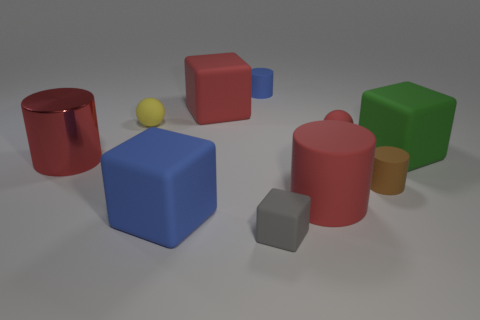The blue block that is made of the same material as the tiny brown object is what size?
Provide a short and direct response. Large. Are there any blue metal things that have the same size as the gray thing?
Offer a terse response. No. What shape is the blue matte thing behind the big red matte thing behind the tiny rubber cylinder on the right side of the tiny cube?
Your answer should be very brief. Cylinder. Is the number of brown objects right of the large red block greater than the number of big gray rubber spheres?
Offer a terse response. Yes. Is there a large green object of the same shape as the gray rubber object?
Ensure brevity in your answer.  Yes. Is the small yellow ball made of the same material as the big red cylinder that is to the right of the small yellow thing?
Offer a terse response. Yes. What is the color of the metallic thing?
Give a very brief answer. Red. There is a cylinder behind the matte ball on the left side of the red matte cube; what number of big blue matte blocks are in front of it?
Your answer should be compact. 1. Are there any red matte spheres on the left side of the tiny red rubber ball?
Provide a short and direct response. No. How many small brown cylinders are the same material as the yellow ball?
Offer a very short reply. 1. 